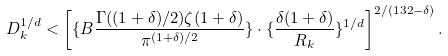<formula> <loc_0><loc_0><loc_500><loc_500>D _ { k } ^ { 1 / d } < \left [ \{ B \frac { \Gamma ( ( 1 + \delta ) / 2 ) \zeta ( 1 + \delta ) } { \pi ^ { ( 1 + \delta ) / 2 } } \} \cdot \{ \frac { \delta ( 1 + \delta ) } { R _ { k } } \} ^ { 1 / d } \right ] ^ { 2 / ( 1 3 2 - \delta ) } .</formula> 